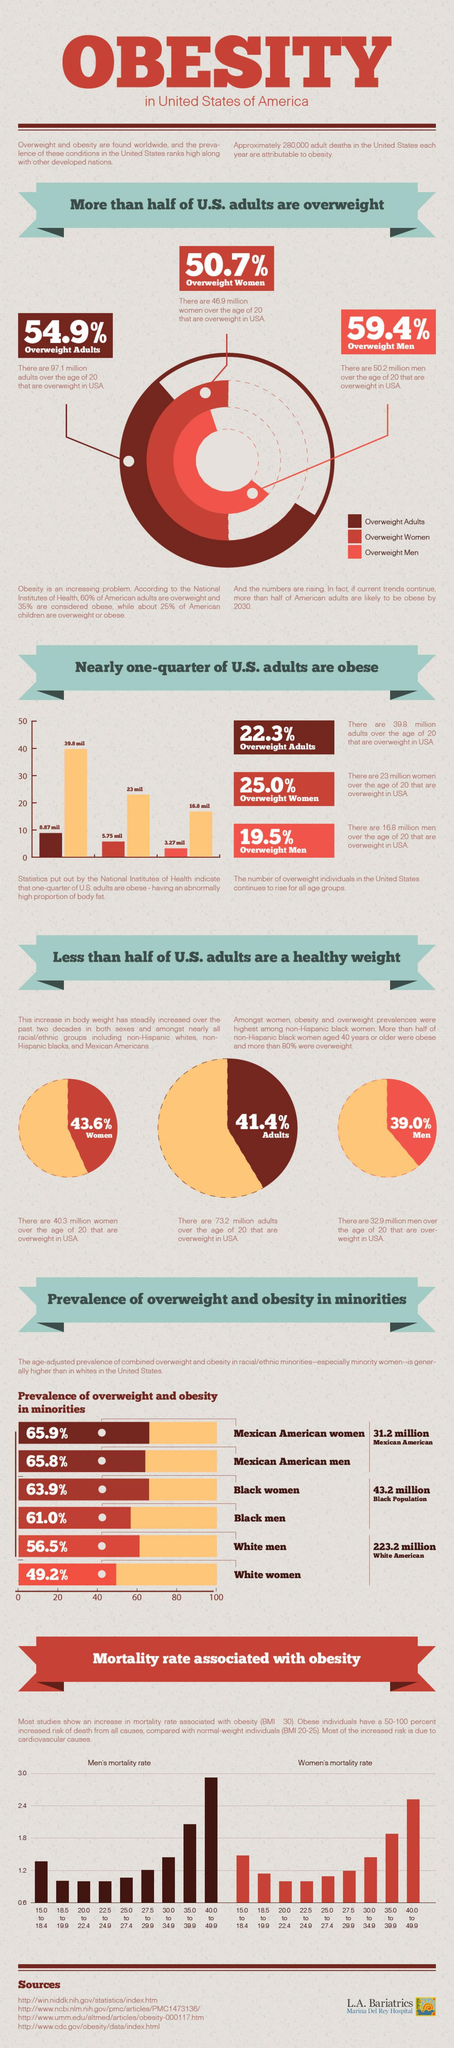Which minority group gender has the second most percentage of overweight and obesity?
Answer the question with a short phrase. Black women Whose mortality rate associated with obesity is higher? Men's Which gender has more overweight adults as per the pie chart? Men 